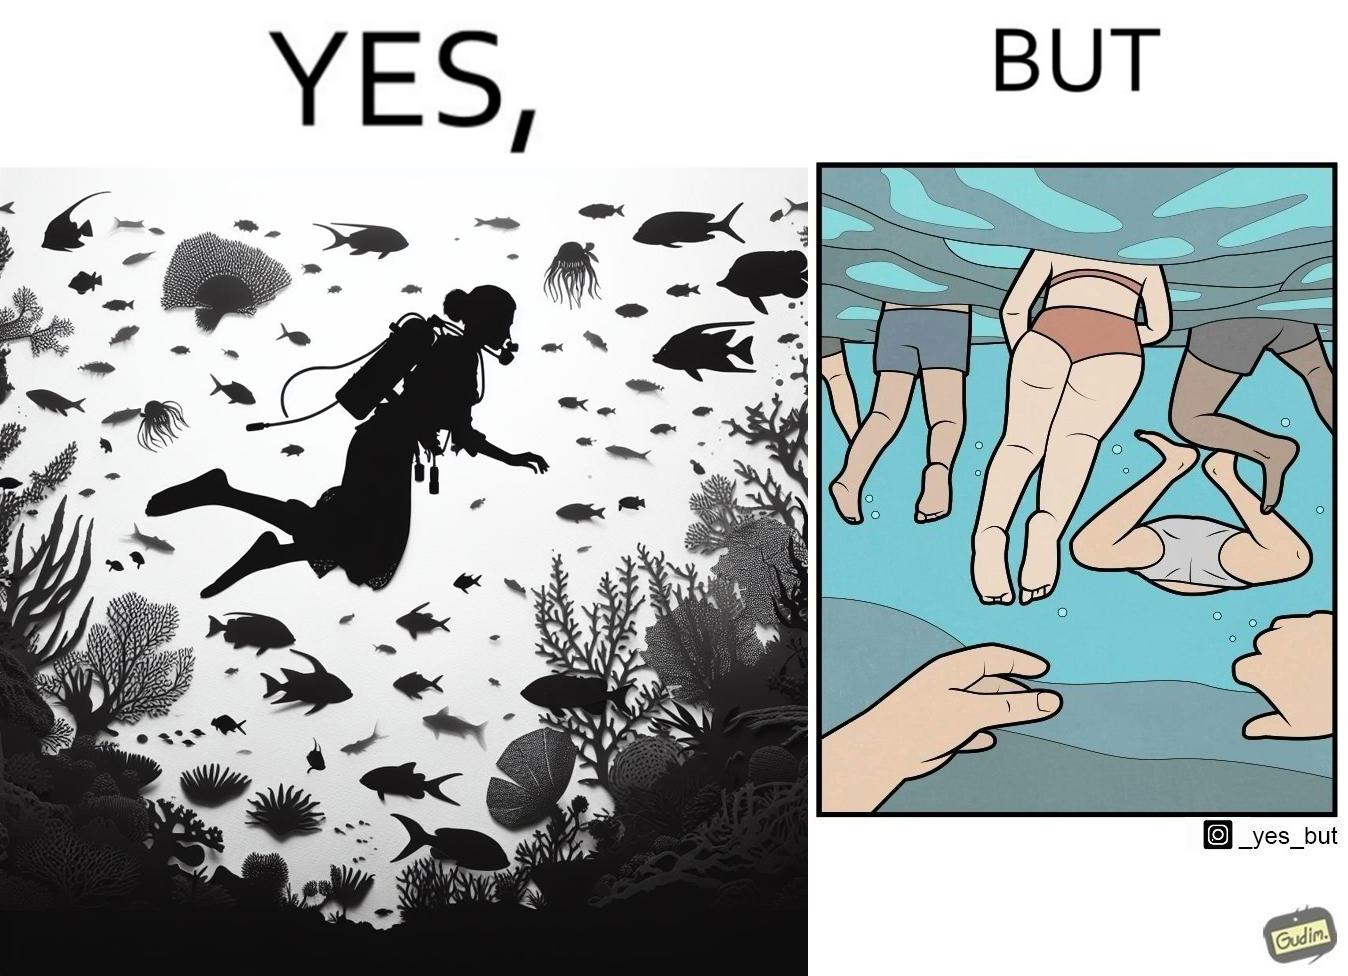Describe the contrast between the left and right parts of this image. In the left part of the image: a person underwater exploring the biodiversity under water In the right part of the image: a person underwater watching people swimming in the water 